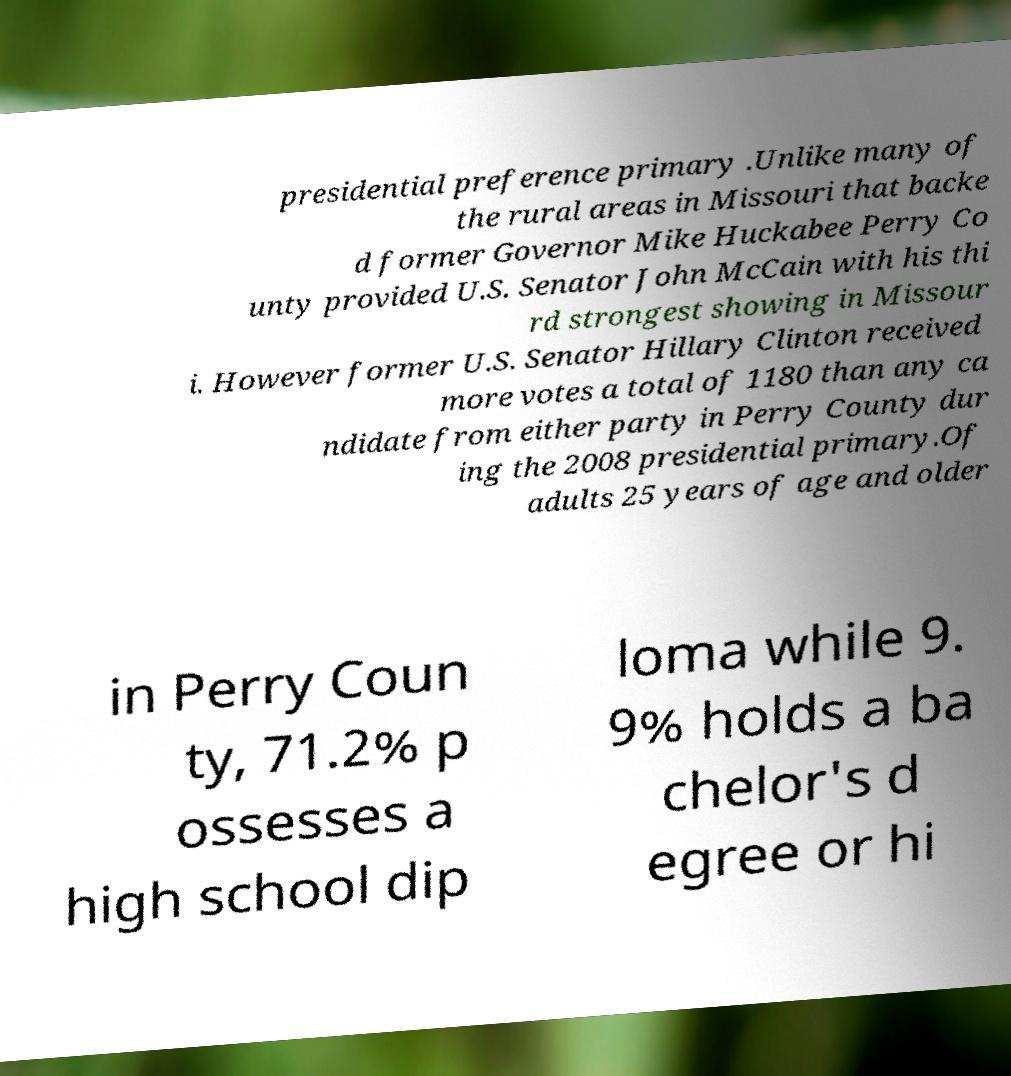Can you read and provide the text displayed in the image?This photo seems to have some interesting text. Can you extract and type it out for me? presidential preference primary .Unlike many of the rural areas in Missouri that backe d former Governor Mike Huckabee Perry Co unty provided U.S. Senator John McCain with his thi rd strongest showing in Missour i. However former U.S. Senator Hillary Clinton received more votes a total of 1180 than any ca ndidate from either party in Perry County dur ing the 2008 presidential primary.Of adults 25 years of age and older in Perry Coun ty, 71.2% p ossesses a high school dip loma while 9. 9% holds a ba chelor's d egree or hi 